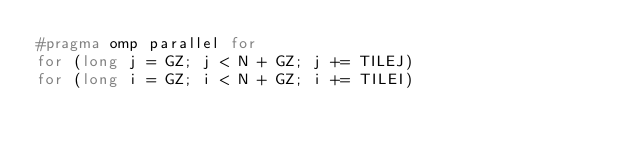<code> <loc_0><loc_0><loc_500><loc_500><_C_>#pragma omp parallel for
for (long j = GZ; j < N + GZ; j += TILEJ)
for (long i = GZ; i < N + GZ; i += TILEI)
</code> 